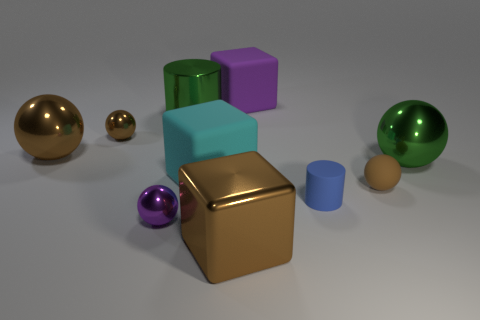How many tiny things are left of the tiny rubber sphere?
Give a very brief answer. 3. Is the number of tiny brown matte things to the left of the brown metal block less than the number of green shiny cylinders right of the blue matte cylinder?
Your answer should be compact. No. There is a purple shiny object to the left of the block behind the cylinder that is to the left of the blue cylinder; what is its shape?
Your response must be concise. Sphere. There is a thing that is behind the cyan cube and right of the tiny blue rubber thing; what shape is it?
Offer a very short reply. Sphere. Are there any large blue spheres made of the same material as the large purple thing?
Offer a terse response. No. The ball that is the same color as the metal cylinder is what size?
Provide a short and direct response. Large. There is a big metal thing that is right of the purple matte cube; what is its color?
Your answer should be very brief. Green. Does the purple rubber object have the same shape as the small metal object on the left side of the purple shiny thing?
Your answer should be very brief. No. Is there a metallic ball that has the same color as the small rubber cylinder?
Make the answer very short. No. What is the size of the purple object that is the same material as the blue cylinder?
Your answer should be very brief. Large. 